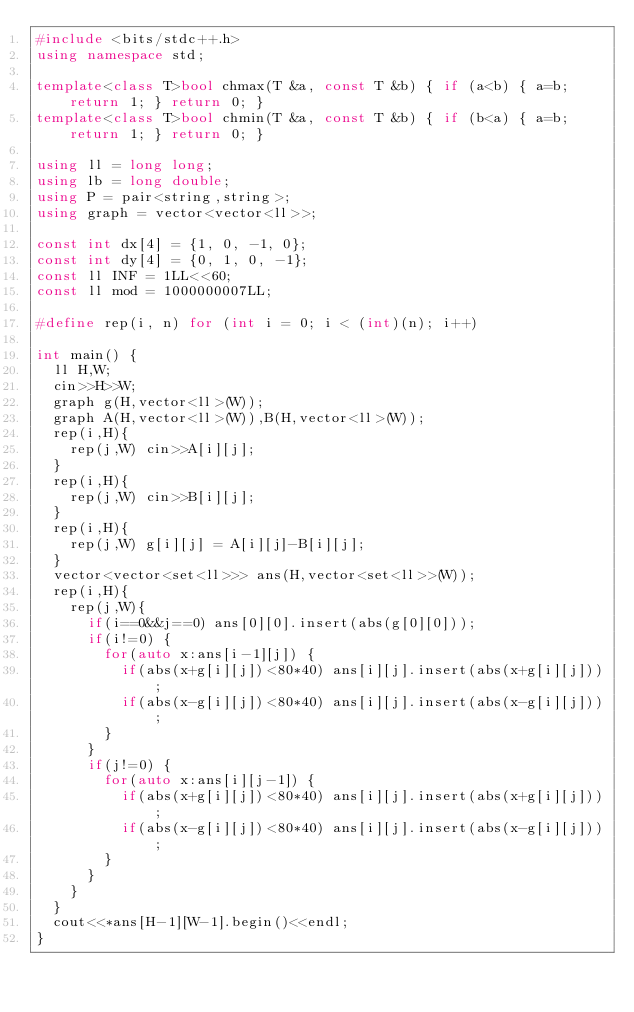<code> <loc_0><loc_0><loc_500><loc_500><_C++_>#include <bits/stdc++.h>
using namespace std;

template<class T>bool chmax(T &a, const T &b) { if (a<b) { a=b; return 1; } return 0; }
template<class T>bool chmin(T &a, const T &b) { if (b<a) { a=b; return 1; } return 0; }

using ll = long long;
using lb = long double;
using P = pair<string,string>;
using graph = vector<vector<ll>>;

const int dx[4] = {1, 0, -1, 0};
const int dy[4] = {0, 1, 0, -1};
const ll INF = 1LL<<60;
const ll mod = 1000000007LL;

#define rep(i, n) for (int i = 0; i < (int)(n); i++)

int main() {
  ll H,W;
  cin>>H>>W;
  graph g(H,vector<ll>(W));
  graph A(H,vector<ll>(W)),B(H,vector<ll>(W));
  rep(i,H){
    rep(j,W) cin>>A[i][j];
  }
  rep(i,H){
    rep(j,W) cin>>B[i][j];
  }
  rep(i,H){
    rep(j,W) g[i][j] = A[i][j]-B[i][j];
  }
  vector<vector<set<ll>>> ans(H,vector<set<ll>>(W));
  rep(i,H){
    rep(j,W){
      if(i==0&&j==0) ans[0][0].insert(abs(g[0][0]));
      if(i!=0) {
        for(auto x:ans[i-1][j]) {
          if(abs(x+g[i][j])<80*40) ans[i][j].insert(abs(x+g[i][j]));
          if(abs(x-g[i][j])<80*40) ans[i][j].insert(abs(x-g[i][j]));
        }
      }
      if(j!=0) {
        for(auto x:ans[i][j-1]) {
          if(abs(x+g[i][j])<80*40) ans[i][j].insert(abs(x+g[i][j]));
          if(abs(x-g[i][j])<80*40) ans[i][j].insert(abs(x-g[i][j]));
        }
      }
    }
  }
  cout<<*ans[H-1][W-1].begin()<<endl;
}
</code> 